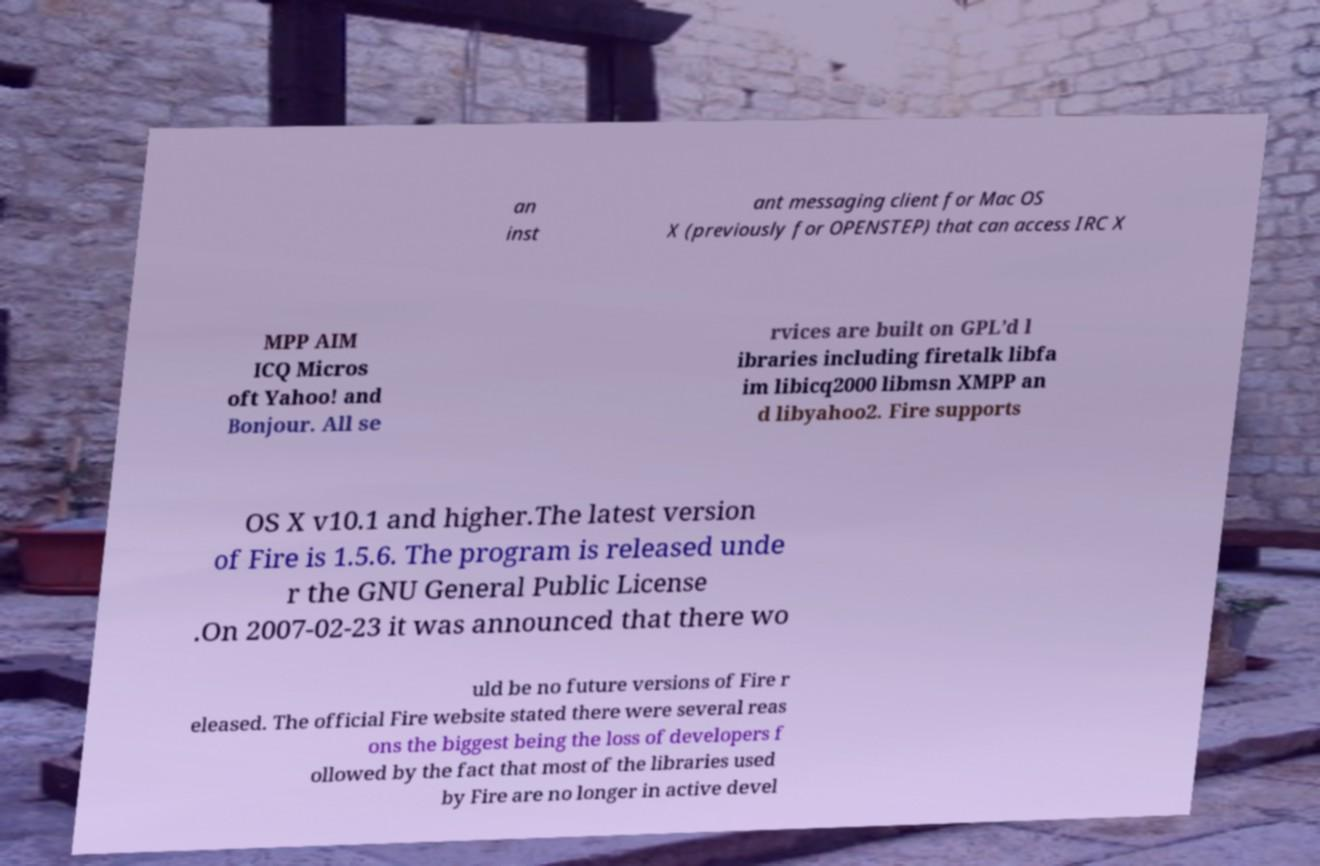For documentation purposes, I need the text within this image transcribed. Could you provide that? an inst ant messaging client for Mac OS X (previously for OPENSTEP) that can access IRC X MPP AIM ICQ Micros oft Yahoo! and Bonjour. All se rvices are built on GPL’d l ibraries including firetalk libfa im libicq2000 libmsn XMPP an d libyahoo2. Fire supports OS X v10.1 and higher.The latest version of Fire is 1.5.6. The program is released unde r the GNU General Public License .On 2007-02-23 it was announced that there wo uld be no future versions of Fire r eleased. The official Fire website stated there were several reas ons the biggest being the loss of developers f ollowed by the fact that most of the libraries used by Fire are no longer in active devel 